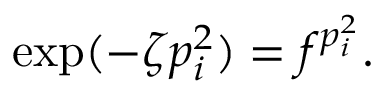Convert formula to latex. <formula><loc_0><loc_0><loc_500><loc_500>\exp ( - \zeta p _ { i } ^ { 2 } ) = f ^ { p _ { i } ^ { 2 } } .</formula> 